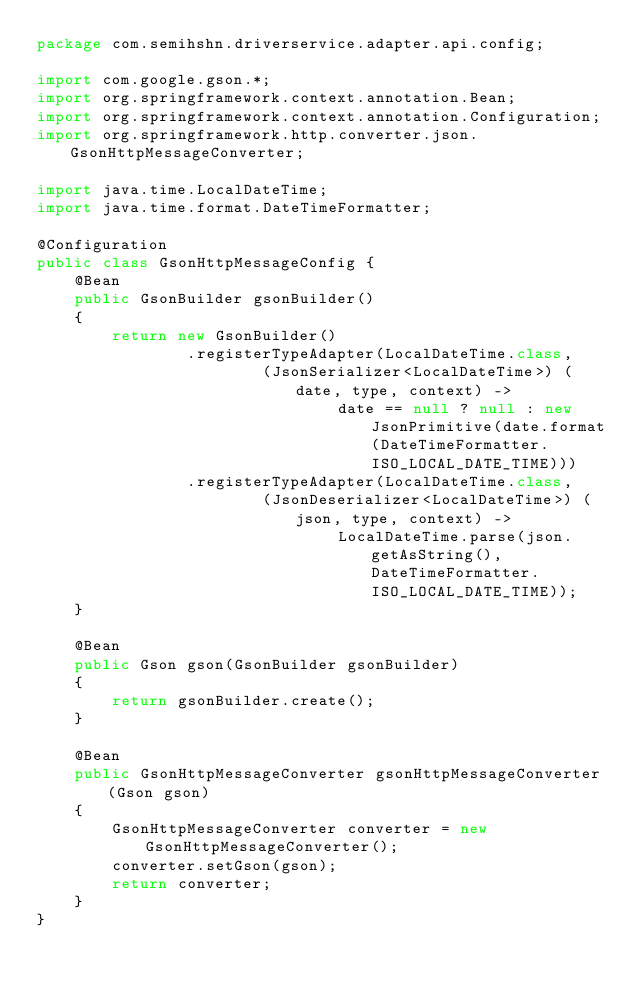Convert code to text. <code><loc_0><loc_0><loc_500><loc_500><_Java_>package com.semihshn.driverservice.adapter.api.config;

import com.google.gson.*;
import org.springframework.context.annotation.Bean;
import org.springframework.context.annotation.Configuration;
import org.springframework.http.converter.json.GsonHttpMessageConverter;

import java.time.LocalDateTime;
import java.time.format.DateTimeFormatter;

@Configuration
public class GsonHttpMessageConfig {
    @Bean
    public GsonBuilder gsonBuilder()
    {
        return new GsonBuilder()
                .registerTypeAdapter(LocalDateTime.class,
                        (JsonSerializer<LocalDateTime>) (date, type, context) ->
                                date == null ? null : new JsonPrimitive(date.format(DateTimeFormatter.ISO_LOCAL_DATE_TIME)))
                .registerTypeAdapter(LocalDateTime.class,
                        (JsonDeserializer<LocalDateTime>) (json, type, context) ->
                                LocalDateTime.parse(json.getAsString(), DateTimeFormatter.ISO_LOCAL_DATE_TIME));
    }

    @Bean
    public Gson gson(GsonBuilder gsonBuilder)
    {
        return gsonBuilder.create();
    }

    @Bean
    public GsonHttpMessageConverter gsonHttpMessageConverter(Gson gson)
    {
        GsonHttpMessageConverter converter = new GsonHttpMessageConverter();
        converter.setGson(gson);
        return converter;
    }
}
</code> 